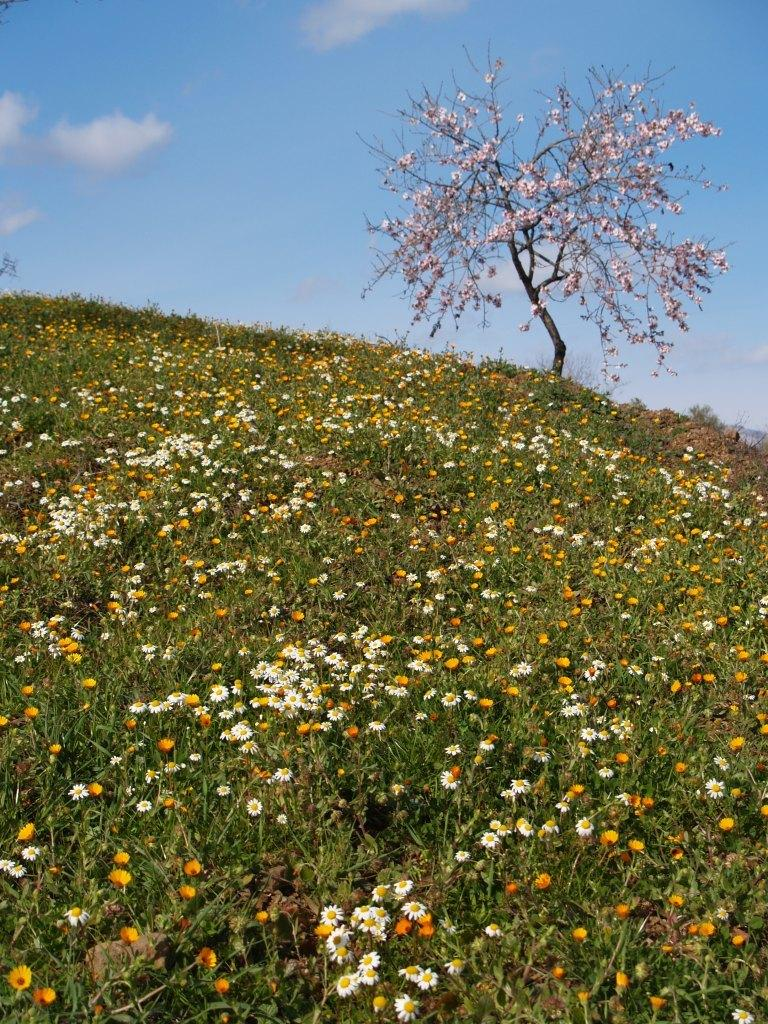What type of location is shown in the image? The image depicts a garden. What can be found in the garden? There are multiple flowers in the garden. What colors are the flowers? The flowers include white, yellow, red, and pink colors. What is visible in the background of the image? The sky is visible in the image. What other plant can be seen in the garden? There is a tree in the image. What type of relation do the bears have with the flowers in the image? There are no bears present in the image, so there is no relation between bears and the flowers. Can you tell me how many grapes are hanging from the tree in the image? There is no tree with grapes in the image; it only features a tree without any fruit. 